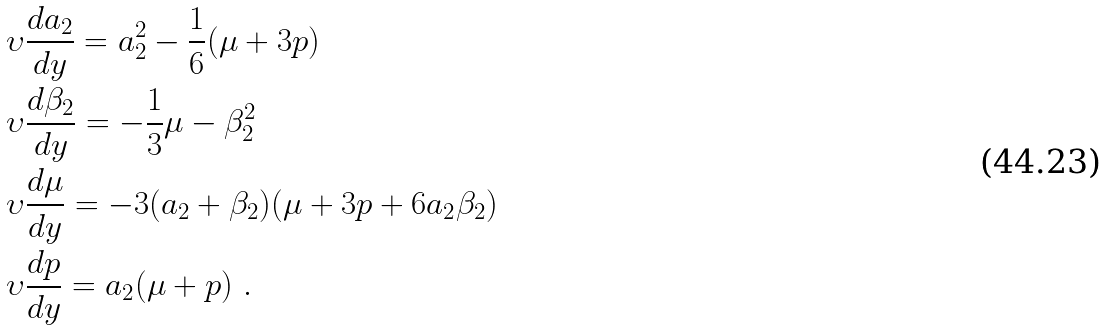<formula> <loc_0><loc_0><loc_500><loc_500>& \upsilon \frac { d a _ { 2 } } { d y } = a _ { 2 } ^ { 2 } - \frac { 1 } { 6 } ( \mu + 3 p ) \\ & \upsilon \frac { d \beta _ { 2 } } { d y } = - \frac { 1 } { 3 } \mu - \beta _ { 2 } ^ { 2 } \\ & \upsilon \frac { d \mu } { d y } = - 3 ( a _ { 2 } + \beta _ { 2 } ) ( \mu + 3 p + 6 a _ { 2 } \beta _ { 2 } ) \\ & \upsilon \frac { d p } { d y } = a _ { 2 } ( \mu + p ) \ .</formula> 